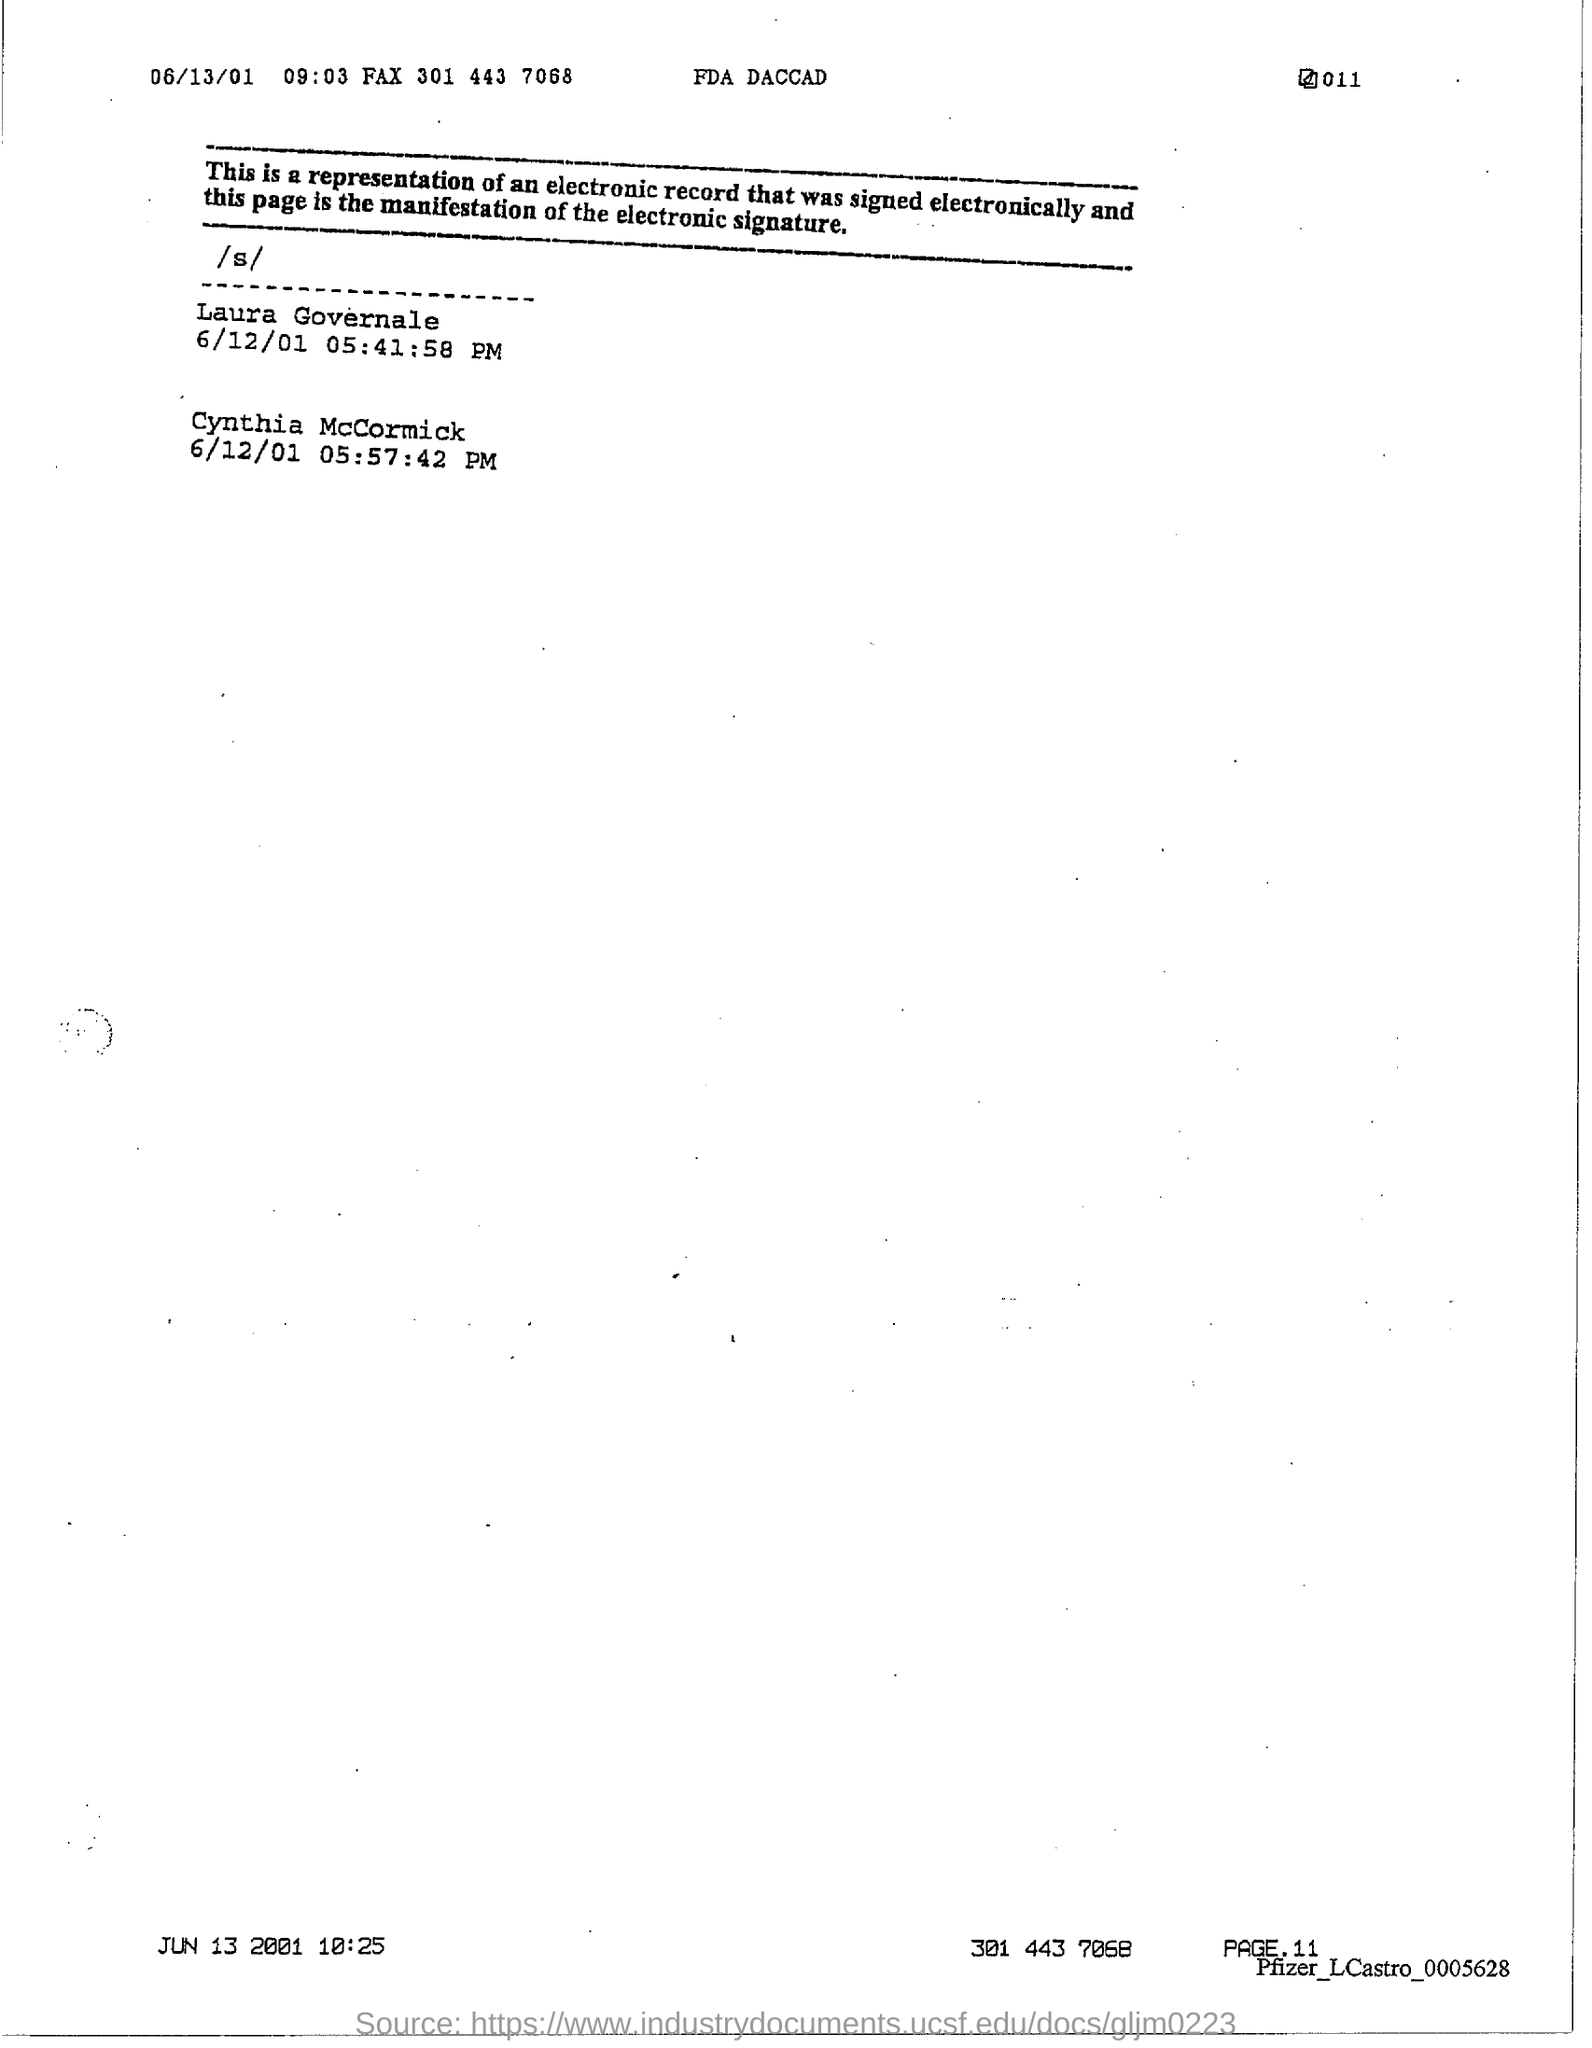What is the page no. at bottom of the page?
Offer a very short reply. 11. 